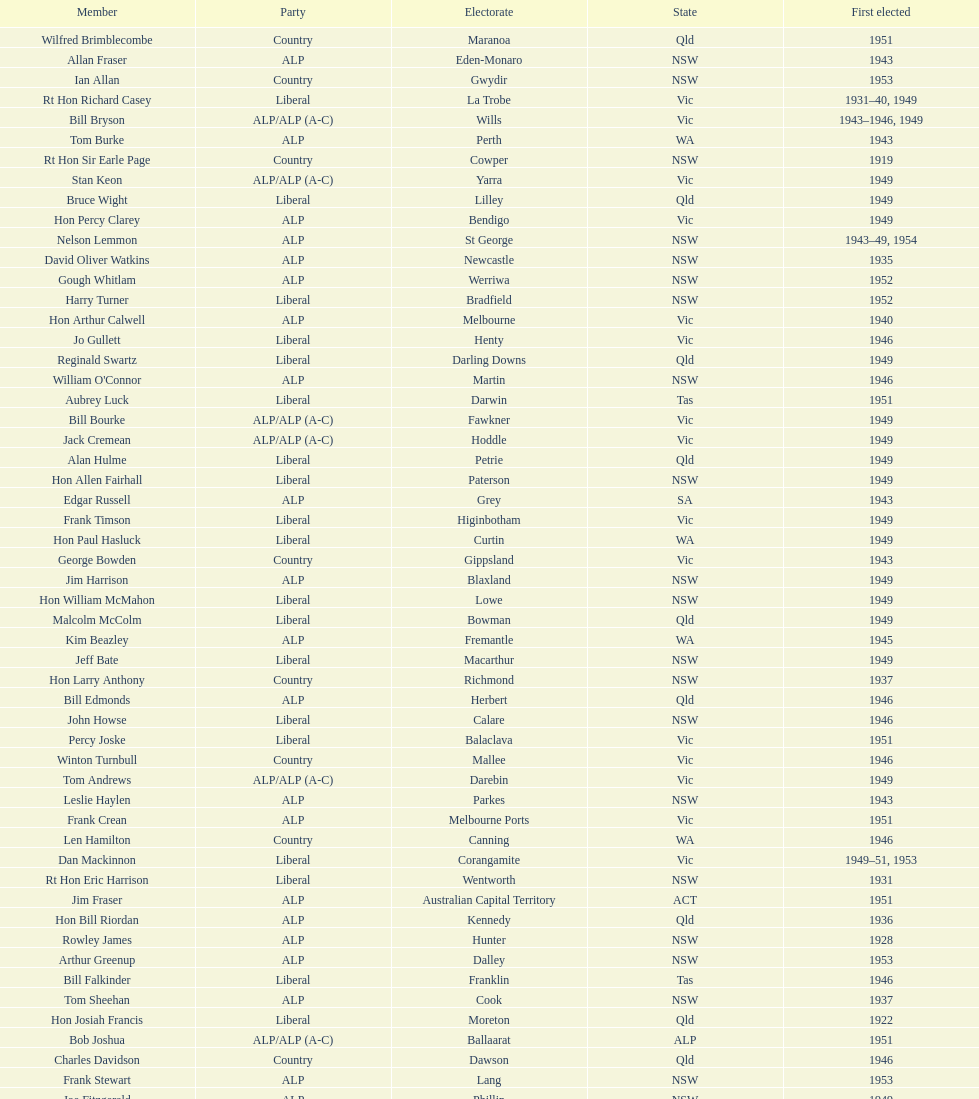Did tom burke run as country or alp party? ALP. 